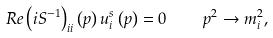Convert formula to latex. <formula><loc_0><loc_0><loc_500><loc_500>R e \left ( i S ^ { - 1 } \right ) _ { i i } \left ( p \right ) u _ { i } ^ { s } \left ( p \right ) = 0 \quad p ^ { 2 } \rightarrow m _ { i } ^ { 2 } ,</formula> 